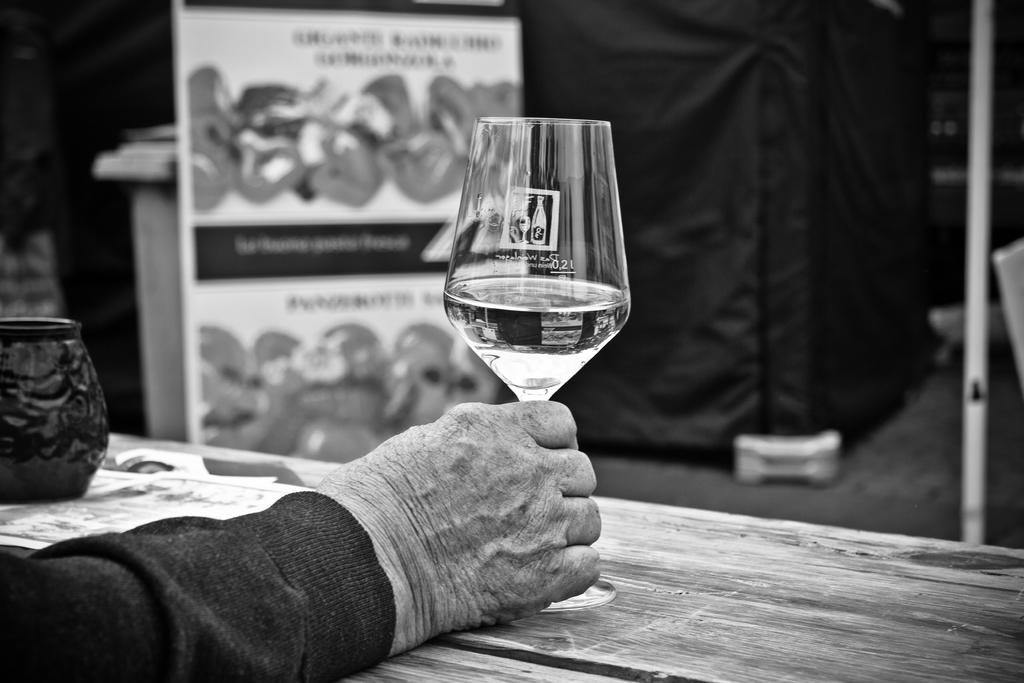What is the person in the image holding? The person is holding a glass in the image. Where is the table located in the image? The table is in the bottom right corner of the image. What can be seen at the top of the image? There is a banner at the top of the image. What type of cracker is being used as a coaster for the glass in the image? There is no cracker present in the image, and the glass is not resting on a coaster. 